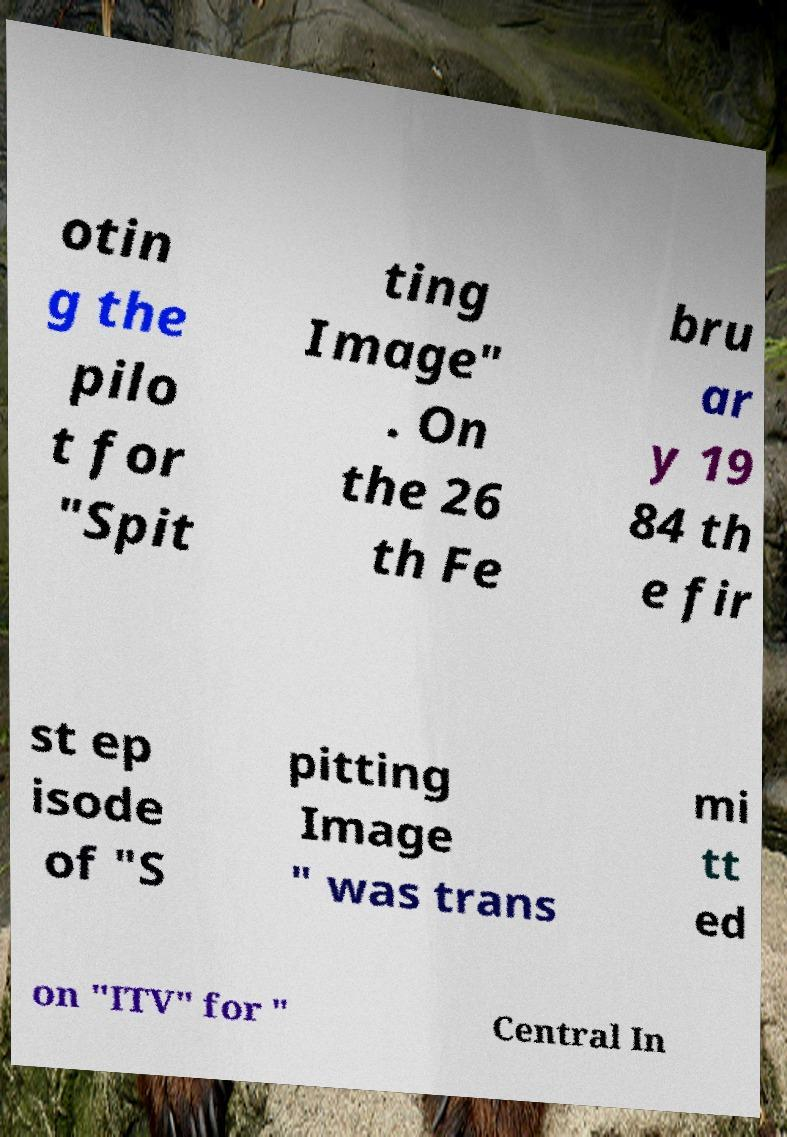Can you read and provide the text displayed in the image?This photo seems to have some interesting text. Can you extract and type it out for me? otin g the pilo t for "Spit ting Image" . On the 26 th Fe bru ar y 19 84 th e fir st ep isode of "S pitting Image " was trans mi tt ed on "ITV" for " Central In 